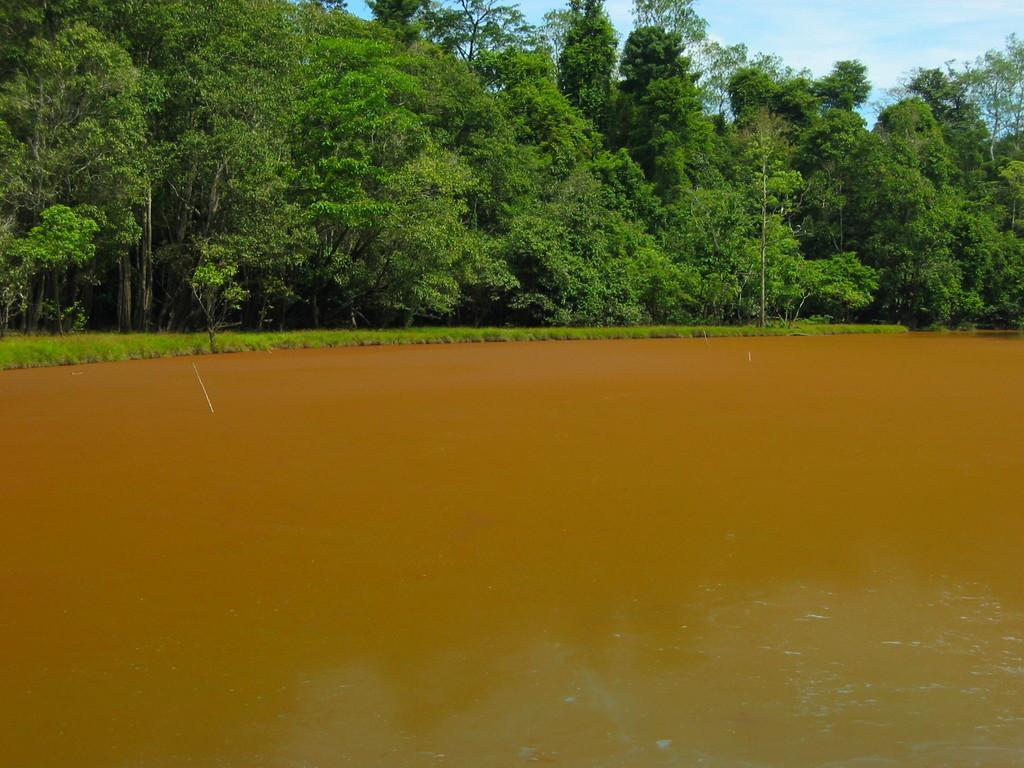How would you summarize this image in a sentence or two? In this image at the bottom there is a river, in the background there are some trees and on the top there is sky. 